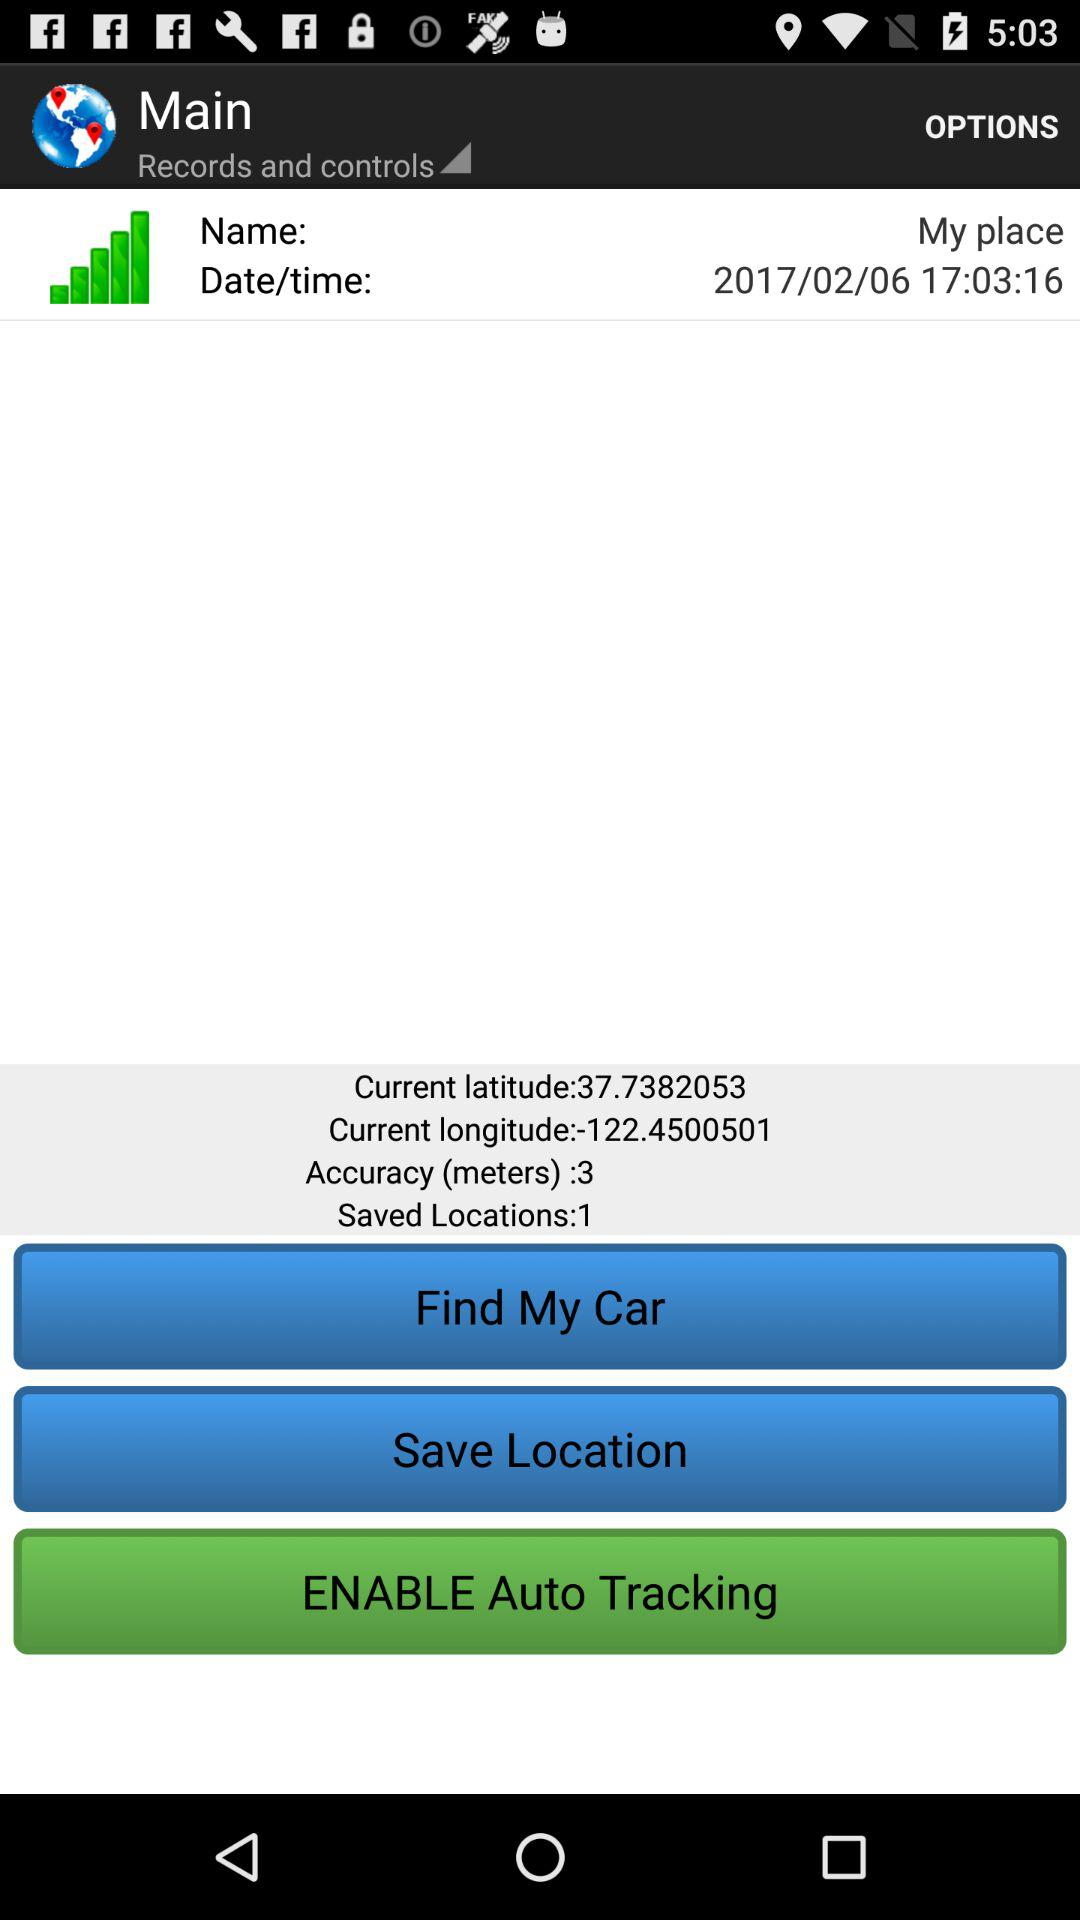How many saved locations are there?
Answer the question using a single word or phrase. 1 